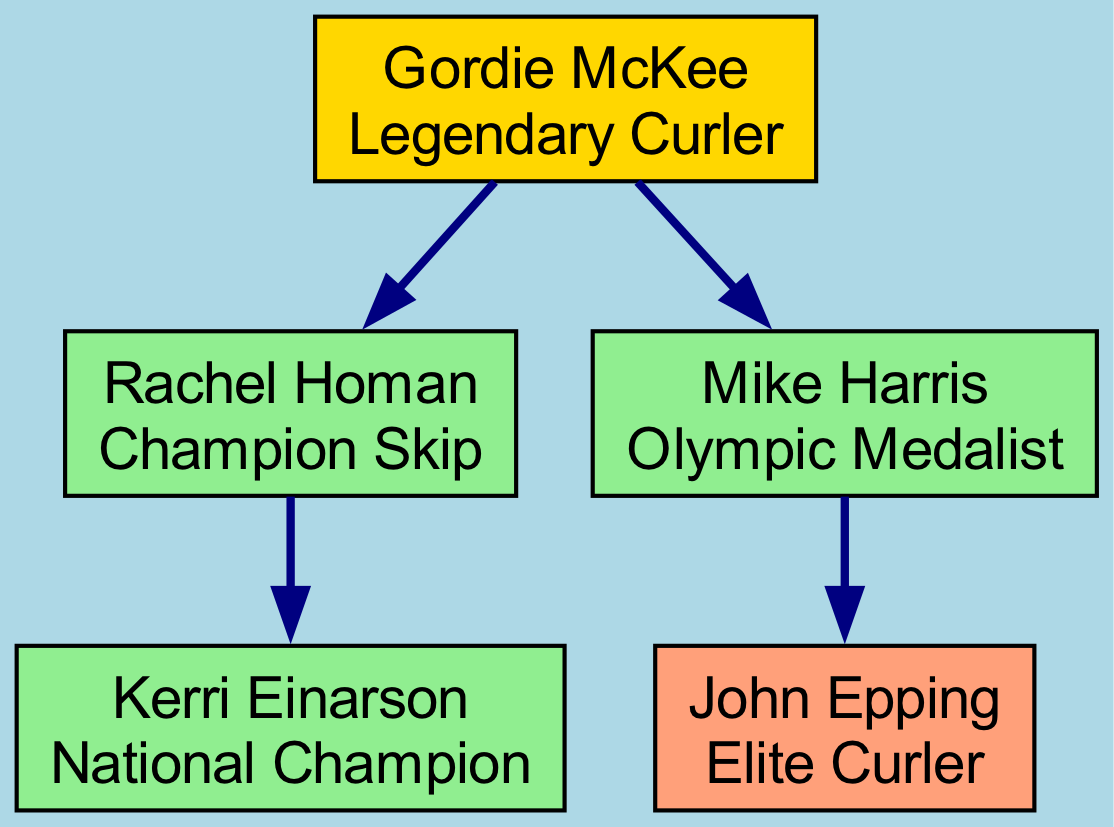What is the role of Gordie McKee? Gordie McKee is labeled as a "Legendary Curler" in the diagram, which identifies his status in the lineage.
Answer: Legendary Curler Who mentored Kerri Einarson? The diagram shows an arrow pointing from Rachel Homan to Kerri Einarson, indicating that Rachel Homan is the mentor.
Answer: Rachel Homan How many mentees does Gordie McKee have? By reviewing the diagram, it is clear that Gordie McKee has two mentees: Rachel Homan and Mike Harris, hence the count is two.
Answer: 2 What color represents Olympic Medalists in the diagram? The color light green is designated for Olympic Medalists as noted in the styling section described in the code.
Answer: Light Green Which curler is mentored by Mike Harris? The arrow from Mike Harris to John Epping indicates that John Epping is mentored by Mike Harris.
Answer: John Epping Who is the only curler that Kerri Einarson has mentored? The diagram specifies that Kerri Einarson has no mentees, thus she has not mentored anyone.
Answer: None What is the relationship between Rachel Homan and Kerri Einarson? Rachel Homan is depicted as the mentor of Kerri Einarson, establishing a direct mentor-mentee relationship between them in the lineage.
Answer: Mentor-Mentee Which node has the least number of outgoing edges? Kerri Einarson has no outgoing edges as she has not mentored anyone, which makes her node the one with the least outgoing connections.
Answer: Kerri Einarson How many total nodes are present in this lineage diagram? By counting the individual nodes in the lineage provided, we find that there are a total of five distinct curlers represented, thus confirming the total.
Answer: 5 